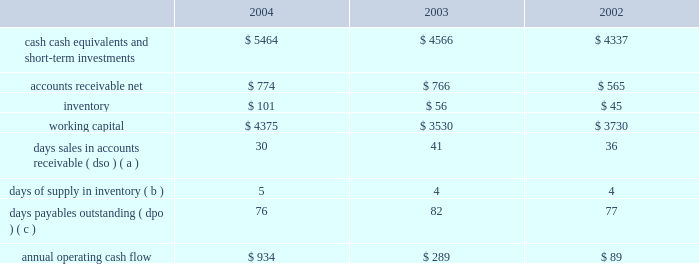Liquidity and capital resources the table presents selected financial information and statistics for each of the last three fiscal years ( dollars in millions ) : .
( a ) dso is based on ending net trade receivables and most recent quarterly net sales for each period .
( b ) days supply of inventory is based on ending inventory and most recent quarterly cost of sales for each period .
( c ) dpo is based on ending accounts payable and most recent quarterly cost of sales adjusted for the change in inventory .
As of september 25 , 2004 , the company had $ 5.464 billion in cash , cash equivalents , and short-term investments , an increase of $ 898 million over the same balances at the end of fiscal 2003 .
The principal components of this increase were cash generated by operating activities of $ 934 million and proceeds of $ 427 million from the issuance of common stock under stock plans , partially offset by cash used to repay the company 2019s outstanding debt of $ 300 million and purchases of property , plant , and equipment of $ 176 million .
The company 2019s short-term investment portfolio is primarily invested in high credit quality , liquid investments .
Approximately $ 3.2 billion of this cash , cash equivalents , and short-term investments are held by the company 2019s foreign subsidiaries and would be subject to u.s .
Income taxation on repatriation to the u.s .
The company is currently assessing the impact of the one-time favorable foreign dividend provisions recently enacted as part of the american jobs creation act of 2004 , and may decide to repatriate earnings from some of its foreign subsidiaries .
The company believes its existing balances of cash , cash equivalents , and short-term investments will be sufficient to satisfy its working capital needs , capital expenditures , stock repurchase activity , outstanding commitments , and other liquidity requirements associated with its existing operations over the next 12 months .
In february 2004 , the company retired $ 300 million of debt outstanding in the form of 6.5% ( 6.5 % ) unsecured notes .
The notes were originally issued in 1994 and were sold at 99.9925% ( 99.9925 % ) of par for an effective yield to maturity of 6.51% ( 6.51 % ) .
The company currently has no long-term debt obligations .
Capital expenditures the company 2019s total capital expenditures were $ 176 million during fiscal 2004 , $ 104 million of which were for retail store facilities and equipment related to the company 2019s retail segment and $ 72 million of which were primarily for corporate infrastructure , including information systems enhancements and operating facilities enhancements and expansions .
The company currently anticipates it will utilize approximately $ 240 million for capital expenditures during 2005 , approximately $ 125 million of which is expected to be utilized for further expansion of the company 2019s retail segment and the remainder utilized to support normal replacement of existing capital assets and enhancements to general information technology infrastructure. .
In february 2004 , the company retired $ 300 million of debt outstanding in the form of 6.5% ( 6.5 % ) unsecured notes . what was the annual interest savings from this retirement?\\n? 
Computations: (300 * 6.5%)
Answer: 19.5. 